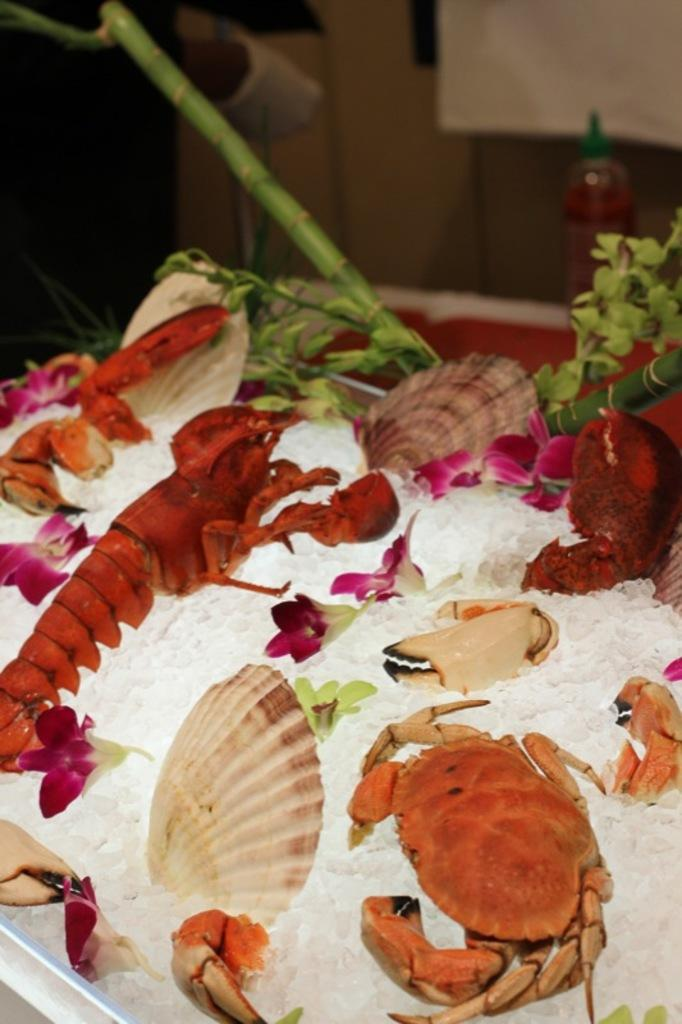What is located in the foreground of the picture? In the foreground of the picture, there is ice, crabs, a plant, and other marine animals. Can you describe the marine animals in the foreground? Unfortunately, the specific marine animals cannot be identified from the provided facts. What is the condition of the background in the image? The background of the image is blurred. What type of beam is holding the airplane in the image? There is no airplane present in the image, so there is no beam holding an airplane. 